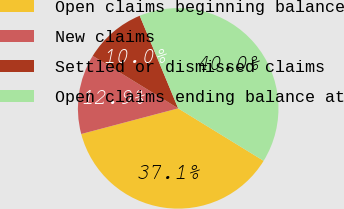Convert chart to OTSL. <chart><loc_0><loc_0><loc_500><loc_500><pie_chart><fcel>Open claims beginning balance<fcel>New claims<fcel>Settled or dismissed claims<fcel>Open claims ending balance at<nl><fcel>37.12%<fcel>12.88%<fcel>9.97%<fcel>40.03%<nl></chart> 